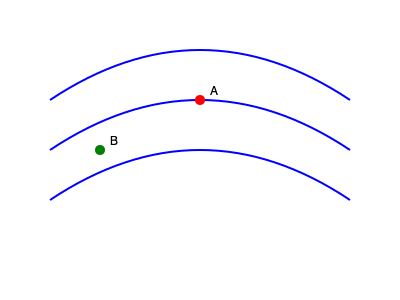In the 2D fluid flow simulation shown above, streamlines are represented by blue curves. Points A and B are marked in red and green, respectively. Based on the streamline pattern, at which point is the fluid velocity higher, and why? To determine where the fluid velocity is higher, we need to analyze the streamline pattern:

1. Streamlines represent the paths that fluid particles would follow in a steady flow.

2. The spacing between streamlines is inversely proportional to the fluid velocity. This is due to the principle of mass conservation in incompressible flows, expressed as:

   $$\nabla \cdot \mathbf{v} = 0$$

   where $\mathbf{v}$ is the velocity vector.

3. Observing the streamline pattern:
   - At point A (red), the streamlines are closer together.
   - At point B (green), the streamlines are farther apart.

4. The closer spacing at point A indicates a higher velocity, as more fluid must pass through a smaller area to maintain continuity.

5. This can be quantified using the stream function $\psi$, where:

   $$v_x = \frac{\partial \psi}{\partial y}, \quad v_y = -\frac{\partial \psi}{\partial x}$$

   The gradient of $\psi$ is steeper at point A, indicating higher velocity components.

6. Additionally, the curvature of the streamlines is greater at point A, suggesting a stronger velocity gradient in that region.

Therefore, based on the streamline pattern, the fluid velocity is higher at point A (red).
Answer: Point A (higher streamline density) 